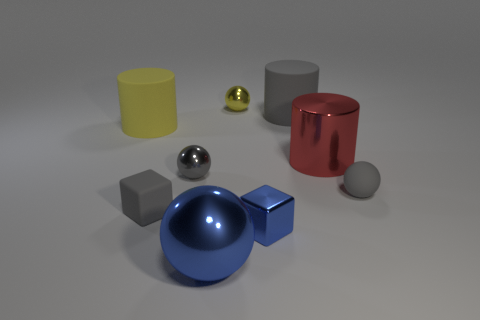What size is the cube that is the same color as the big metallic ball?
Keep it short and to the point. Small. There is a blue metallic object that is the same shape as the tiny gray shiny object; what size is it?
Keep it short and to the point. Large. What shape is the tiny metal object that is behind the cylinder to the left of the big gray object?
Keep it short and to the point. Sphere. What size is the blue ball?
Provide a succinct answer. Large. What shape is the tiny blue object?
Make the answer very short. Cube. Do the tiny yellow object and the tiny shiny object that is to the left of the yellow metal ball have the same shape?
Give a very brief answer. Yes. Does the big matte thing that is on the left side of the tiny shiny cube have the same shape as the large blue object?
Ensure brevity in your answer.  No. How many cylinders are both behind the shiny cylinder and to the right of the yellow cylinder?
Provide a short and direct response. 1. How many other things are the same size as the gray metallic sphere?
Give a very brief answer. 4. Are there the same number of cylinders to the right of the tiny blue metal thing and large green matte objects?
Offer a very short reply. No. 